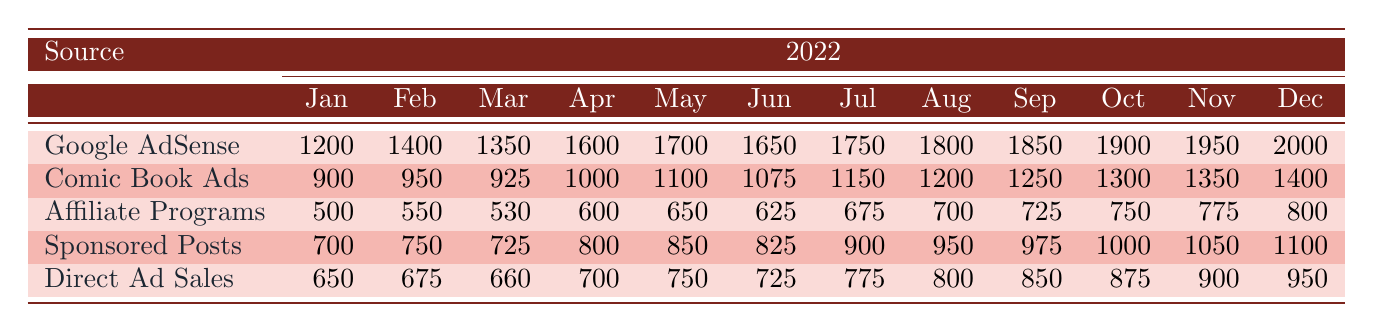What was the highest revenue source in December 2022? The highest revenue source can be identified by comparing the December values of each source: Google AdSense (2000), Comic Book Ads (1400), Affiliate Programs (800), Sponsored Posts (1100), Direct Ad Sales (950). The highest value is from Google AdSense.
Answer: Google AdSense Which month saw the lowest revenue from Affiliate Programs? The revenue values for Affiliate Programs by month are: January (500), February (550), March (530), April (600), May (650), June (625), July (675), August (700), September (725), October (750), November (775), December (800). The lowest value is in January at 500.
Answer: January What is the total revenue from Sponsored Posts in the first half of 2022? The first half of 2022 includes January to June. The revenue for Sponsored Posts in these months is: 700 + 750 + 725 + 800 + 850 + 825 = 4850.
Answer: 4850 Did Google AdSense generate more revenue than Comic Book Ads in September 2022? The September revenue for Google AdSense is 1850 and for Comic Book Ads is 1250. Since 1850 is greater than 1250, the statement is true.
Answer: Yes What was the percentage increase of Direct Ad Sales from January to December 2022? The revenue in January for Direct Ad Sales is 650, and in December it is 950. The increase is 950 - 650 = 300. The percentage increase is (300 / 650) * 100 = 46.15%.
Answer: 46.15% 